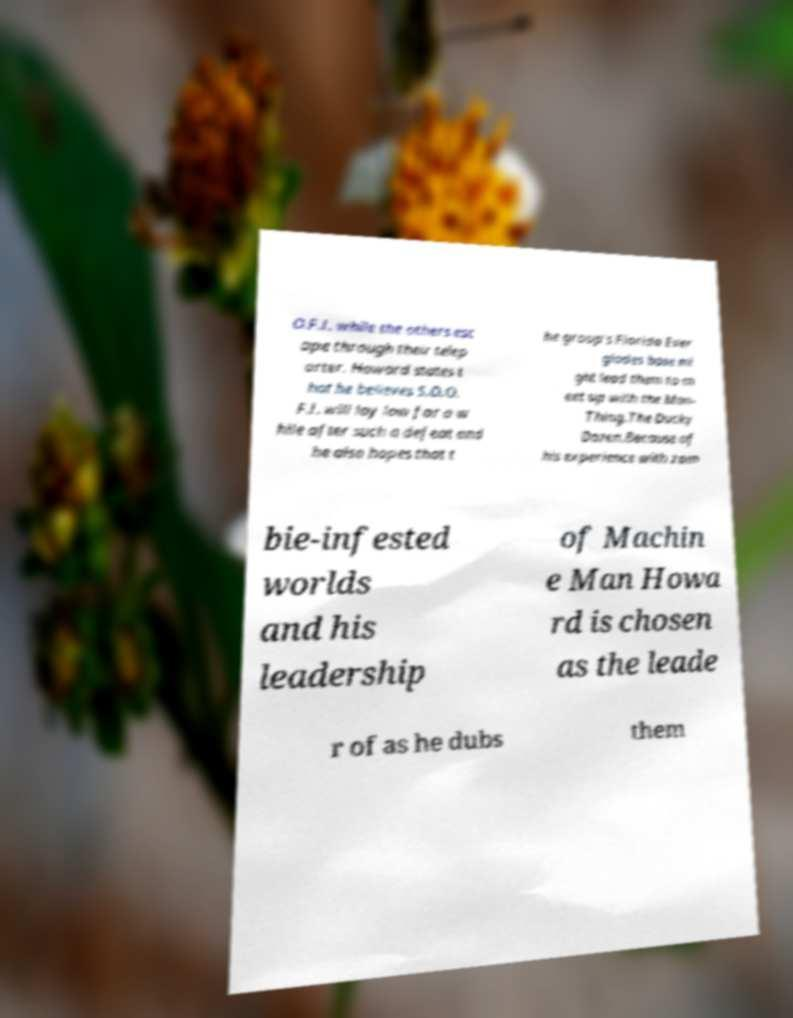Can you accurately transcribe the text from the provided image for me? O.F.I. while the others esc ape through their telep orter. Howard states t hat he believes S.O.O. F.I. will lay low for a w hile after such a defeat and he also hopes that t he group's Florida Ever glades base mi ght lead them to m eet up with the Man- Thing.The Ducky Dozen.Because of his experience with zom bie-infested worlds and his leadership of Machin e Man Howa rd is chosen as the leade r of as he dubs them 